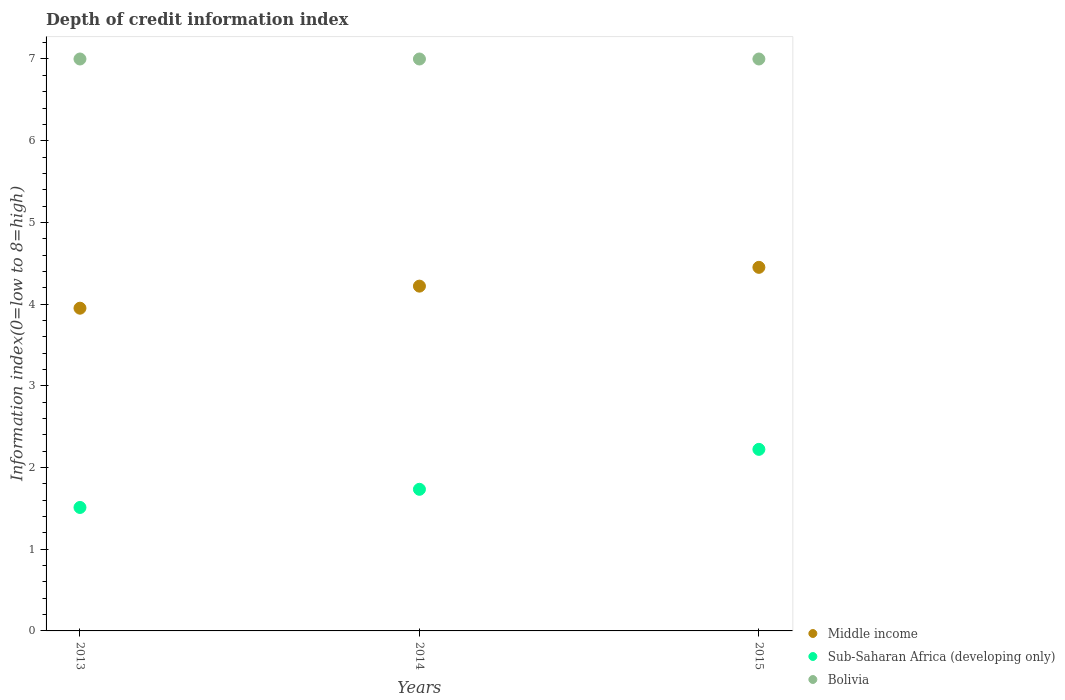How many different coloured dotlines are there?
Your answer should be compact. 3. What is the information index in Bolivia in 2015?
Offer a very short reply. 7. Across all years, what is the maximum information index in Sub-Saharan Africa (developing only)?
Ensure brevity in your answer.  2.22. Across all years, what is the minimum information index in Sub-Saharan Africa (developing only)?
Provide a succinct answer. 1.51. In which year was the information index in Bolivia minimum?
Your response must be concise. 2013. What is the total information index in Middle income in the graph?
Offer a terse response. 12.62. What is the difference between the information index in Middle income in 2014 and that in 2015?
Provide a short and direct response. -0.23. What is the difference between the information index in Sub-Saharan Africa (developing only) in 2015 and the information index in Bolivia in 2014?
Keep it short and to the point. -4.78. What is the average information index in Middle income per year?
Give a very brief answer. 4.21. In the year 2014, what is the difference between the information index in Bolivia and information index in Middle income?
Your answer should be compact. 2.78. What is the ratio of the information index in Bolivia in 2013 to that in 2014?
Your answer should be compact. 1. Is the information index in Bolivia in 2013 less than that in 2014?
Offer a very short reply. No. Is the difference between the information index in Bolivia in 2013 and 2015 greater than the difference between the information index in Middle income in 2013 and 2015?
Your answer should be compact. Yes. What is the difference between the highest and the second highest information index in Middle income?
Your answer should be compact. 0.23. In how many years, is the information index in Middle income greater than the average information index in Middle income taken over all years?
Offer a terse response. 2. Does the information index in Sub-Saharan Africa (developing only) monotonically increase over the years?
Provide a short and direct response. Yes. Is the information index in Sub-Saharan Africa (developing only) strictly less than the information index in Bolivia over the years?
Provide a succinct answer. Yes. What is the difference between two consecutive major ticks on the Y-axis?
Your answer should be compact. 1. Are the values on the major ticks of Y-axis written in scientific E-notation?
Ensure brevity in your answer.  No. Does the graph contain any zero values?
Keep it short and to the point. No. Does the graph contain grids?
Ensure brevity in your answer.  No. What is the title of the graph?
Your answer should be very brief. Depth of credit information index. Does "Czech Republic" appear as one of the legend labels in the graph?
Your response must be concise. No. What is the label or title of the X-axis?
Your answer should be compact. Years. What is the label or title of the Y-axis?
Your answer should be compact. Information index(0=low to 8=high). What is the Information index(0=low to 8=high) in Middle income in 2013?
Offer a very short reply. 3.95. What is the Information index(0=low to 8=high) in Sub-Saharan Africa (developing only) in 2013?
Keep it short and to the point. 1.51. What is the Information index(0=low to 8=high) in Bolivia in 2013?
Your answer should be very brief. 7. What is the Information index(0=low to 8=high) of Middle income in 2014?
Your answer should be compact. 4.22. What is the Information index(0=low to 8=high) of Sub-Saharan Africa (developing only) in 2014?
Give a very brief answer. 1.73. What is the Information index(0=low to 8=high) of Bolivia in 2014?
Make the answer very short. 7. What is the Information index(0=low to 8=high) of Middle income in 2015?
Offer a terse response. 4.45. What is the Information index(0=low to 8=high) of Sub-Saharan Africa (developing only) in 2015?
Your answer should be very brief. 2.22. What is the Information index(0=low to 8=high) in Bolivia in 2015?
Your answer should be compact. 7. Across all years, what is the maximum Information index(0=low to 8=high) in Middle income?
Ensure brevity in your answer.  4.45. Across all years, what is the maximum Information index(0=low to 8=high) in Sub-Saharan Africa (developing only)?
Your response must be concise. 2.22. Across all years, what is the minimum Information index(0=low to 8=high) of Middle income?
Make the answer very short. 3.95. Across all years, what is the minimum Information index(0=low to 8=high) of Sub-Saharan Africa (developing only)?
Provide a short and direct response. 1.51. What is the total Information index(0=low to 8=high) of Middle income in the graph?
Offer a terse response. 12.62. What is the total Information index(0=low to 8=high) in Sub-Saharan Africa (developing only) in the graph?
Your answer should be compact. 5.47. What is the difference between the Information index(0=low to 8=high) of Middle income in 2013 and that in 2014?
Your response must be concise. -0.27. What is the difference between the Information index(0=low to 8=high) in Sub-Saharan Africa (developing only) in 2013 and that in 2014?
Ensure brevity in your answer.  -0.22. What is the difference between the Information index(0=low to 8=high) of Bolivia in 2013 and that in 2014?
Your response must be concise. 0. What is the difference between the Information index(0=low to 8=high) in Middle income in 2013 and that in 2015?
Ensure brevity in your answer.  -0.5. What is the difference between the Information index(0=low to 8=high) in Sub-Saharan Africa (developing only) in 2013 and that in 2015?
Your response must be concise. -0.71. What is the difference between the Information index(0=low to 8=high) in Middle income in 2014 and that in 2015?
Provide a succinct answer. -0.23. What is the difference between the Information index(0=low to 8=high) in Sub-Saharan Africa (developing only) in 2014 and that in 2015?
Keep it short and to the point. -0.49. What is the difference between the Information index(0=low to 8=high) in Bolivia in 2014 and that in 2015?
Your answer should be compact. 0. What is the difference between the Information index(0=low to 8=high) of Middle income in 2013 and the Information index(0=low to 8=high) of Sub-Saharan Africa (developing only) in 2014?
Your answer should be compact. 2.22. What is the difference between the Information index(0=low to 8=high) of Middle income in 2013 and the Information index(0=low to 8=high) of Bolivia in 2014?
Keep it short and to the point. -3.05. What is the difference between the Information index(0=low to 8=high) in Sub-Saharan Africa (developing only) in 2013 and the Information index(0=low to 8=high) in Bolivia in 2014?
Offer a very short reply. -5.49. What is the difference between the Information index(0=low to 8=high) in Middle income in 2013 and the Information index(0=low to 8=high) in Sub-Saharan Africa (developing only) in 2015?
Give a very brief answer. 1.73. What is the difference between the Information index(0=low to 8=high) of Middle income in 2013 and the Information index(0=low to 8=high) of Bolivia in 2015?
Your response must be concise. -3.05. What is the difference between the Information index(0=low to 8=high) in Sub-Saharan Africa (developing only) in 2013 and the Information index(0=low to 8=high) in Bolivia in 2015?
Provide a succinct answer. -5.49. What is the difference between the Information index(0=low to 8=high) in Middle income in 2014 and the Information index(0=low to 8=high) in Sub-Saharan Africa (developing only) in 2015?
Give a very brief answer. 2. What is the difference between the Information index(0=low to 8=high) in Middle income in 2014 and the Information index(0=low to 8=high) in Bolivia in 2015?
Your answer should be very brief. -2.78. What is the difference between the Information index(0=low to 8=high) in Sub-Saharan Africa (developing only) in 2014 and the Information index(0=low to 8=high) in Bolivia in 2015?
Your response must be concise. -5.27. What is the average Information index(0=low to 8=high) in Middle income per year?
Provide a succinct answer. 4.21. What is the average Information index(0=low to 8=high) in Sub-Saharan Africa (developing only) per year?
Make the answer very short. 1.82. What is the average Information index(0=low to 8=high) of Bolivia per year?
Your answer should be compact. 7. In the year 2013, what is the difference between the Information index(0=low to 8=high) in Middle income and Information index(0=low to 8=high) in Sub-Saharan Africa (developing only)?
Offer a very short reply. 2.44. In the year 2013, what is the difference between the Information index(0=low to 8=high) in Middle income and Information index(0=low to 8=high) in Bolivia?
Your answer should be very brief. -3.05. In the year 2013, what is the difference between the Information index(0=low to 8=high) in Sub-Saharan Africa (developing only) and Information index(0=low to 8=high) in Bolivia?
Keep it short and to the point. -5.49. In the year 2014, what is the difference between the Information index(0=low to 8=high) in Middle income and Information index(0=low to 8=high) in Sub-Saharan Africa (developing only)?
Provide a short and direct response. 2.49. In the year 2014, what is the difference between the Information index(0=low to 8=high) in Middle income and Information index(0=low to 8=high) in Bolivia?
Make the answer very short. -2.78. In the year 2014, what is the difference between the Information index(0=low to 8=high) of Sub-Saharan Africa (developing only) and Information index(0=low to 8=high) of Bolivia?
Provide a short and direct response. -5.27. In the year 2015, what is the difference between the Information index(0=low to 8=high) in Middle income and Information index(0=low to 8=high) in Sub-Saharan Africa (developing only)?
Make the answer very short. 2.23. In the year 2015, what is the difference between the Information index(0=low to 8=high) of Middle income and Information index(0=low to 8=high) of Bolivia?
Ensure brevity in your answer.  -2.55. In the year 2015, what is the difference between the Information index(0=low to 8=high) of Sub-Saharan Africa (developing only) and Information index(0=low to 8=high) of Bolivia?
Offer a terse response. -4.78. What is the ratio of the Information index(0=low to 8=high) of Middle income in 2013 to that in 2014?
Your answer should be very brief. 0.94. What is the ratio of the Information index(0=low to 8=high) of Sub-Saharan Africa (developing only) in 2013 to that in 2014?
Ensure brevity in your answer.  0.87. What is the ratio of the Information index(0=low to 8=high) in Bolivia in 2013 to that in 2014?
Make the answer very short. 1. What is the ratio of the Information index(0=low to 8=high) in Middle income in 2013 to that in 2015?
Make the answer very short. 0.89. What is the ratio of the Information index(0=low to 8=high) of Sub-Saharan Africa (developing only) in 2013 to that in 2015?
Your answer should be compact. 0.68. What is the ratio of the Information index(0=low to 8=high) of Bolivia in 2013 to that in 2015?
Make the answer very short. 1. What is the ratio of the Information index(0=low to 8=high) in Middle income in 2014 to that in 2015?
Your answer should be very brief. 0.95. What is the ratio of the Information index(0=low to 8=high) in Sub-Saharan Africa (developing only) in 2014 to that in 2015?
Offer a very short reply. 0.78. What is the ratio of the Information index(0=low to 8=high) of Bolivia in 2014 to that in 2015?
Provide a succinct answer. 1. What is the difference between the highest and the second highest Information index(0=low to 8=high) of Middle income?
Provide a short and direct response. 0.23. What is the difference between the highest and the second highest Information index(0=low to 8=high) in Sub-Saharan Africa (developing only)?
Ensure brevity in your answer.  0.49. What is the difference between the highest and the lowest Information index(0=low to 8=high) of Middle income?
Your answer should be very brief. 0.5. What is the difference between the highest and the lowest Information index(0=low to 8=high) of Sub-Saharan Africa (developing only)?
Ensure brevity in your answer.  0.71. 